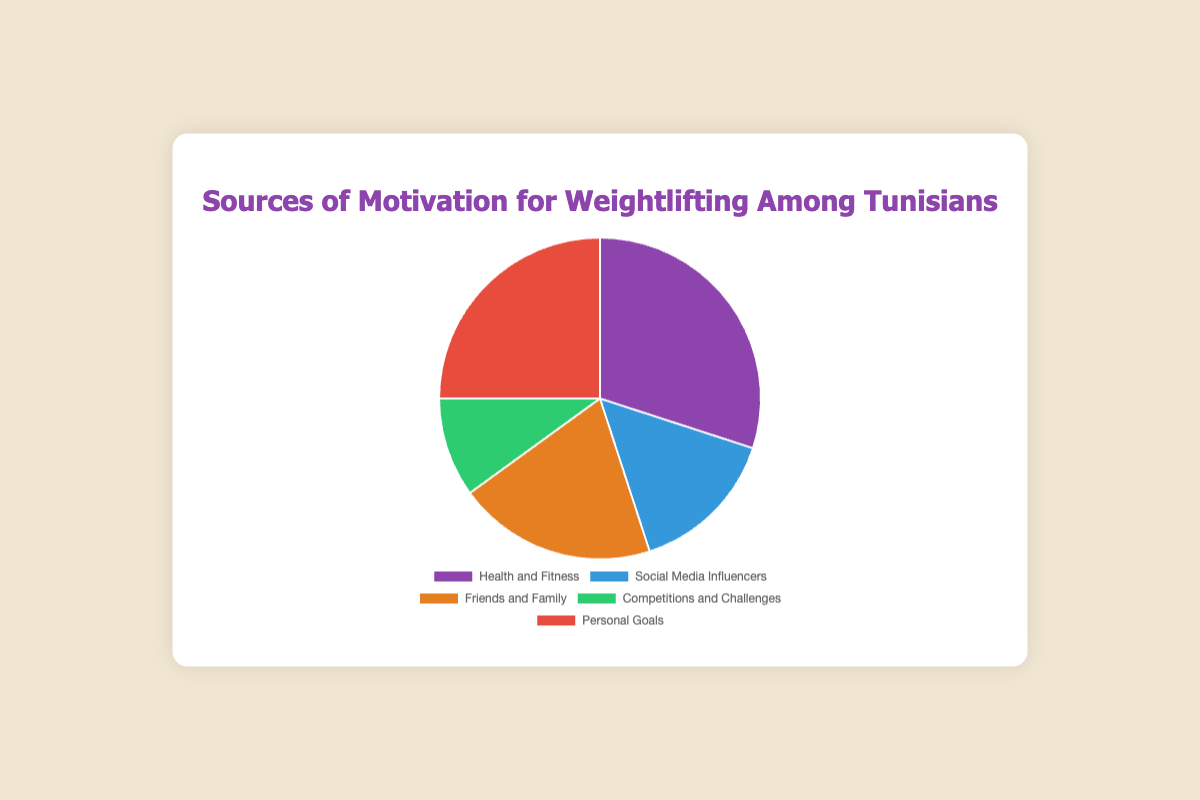What is the largest source of motivation for weightlifting among Tunisians? By looking at the pie chart, the segment labeled "Health and Fitness" is the largest. Therefore, "Health and Fitness" is the largest source of motivation.
Answer: Health and Fitness Which source of motivation has the smallest percentage? Observing the pie chart, the smallest segment is labeled "Competitions and Challenges," which has a percentage of 10.
Answer: Competitions and Challenges What is the combined percentage of people motivated by Social Media Influencers and Competitions and Challenges? Adding the percentages of "Social Media Influencers" (15%) and "Competitions and Challenges" (10%) gives 15 + 10 = 25.
Answer: 25% Is the percentage of people motivated by Personal Goals greater than those motivated by Friends and Family? The pie chart shows the percentage for Personal Goals is 25% and for Friends and Family is 20%. Since 25 is greater than 20, the answer is yes.
Answer: Yes Which source has a red segment in the pie chart? By scanning the colors of the segments, the red segment corresponds to the source "Personal Goals."
Answer: Personal Goals How much greater is the percentage for Health and Fitness compared to Social Media Influencers? The percentage for Health and Fitness is 30%, and for Social Media Influencers, it's 15%. The difference is 30 - 15 = 15.
Answer: 15% What is the total percentage for the top two sources of motivation combined? The top two sources are "Health and Fitness" (30%) and "Personal Goals" (25%). Adding these gives 30 + 25 = 55.
Answer: 55% What is the average percentage of all the motivation sources? The percentages are 30, 15, 20, 10, and 25. The sum is 100, and there are 5 sources. The average is 100 / 5 = 20.
Answer: 20% Is the percentage for Friends and Family equal to the average percentage of all motivation sources? The percentage for Friends and Family is 20%. The average percentage calculated previously is also 20%. Therefore, they are equal.
Answer: Yes 